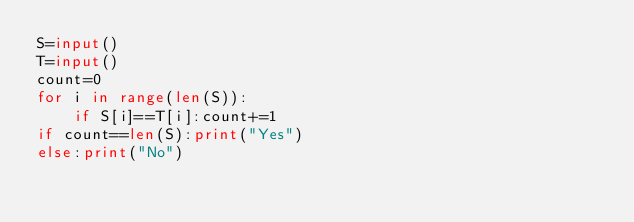Convert code to text. <code><loc_0><loc_0><loc_500><loc_500><_Python_>S=input()
T=input()
count=0
for i in range(len(S)):
    if S[i]==T[i]:count+=1
if count==len(S):print("Yes")
else:print("No")</code> 